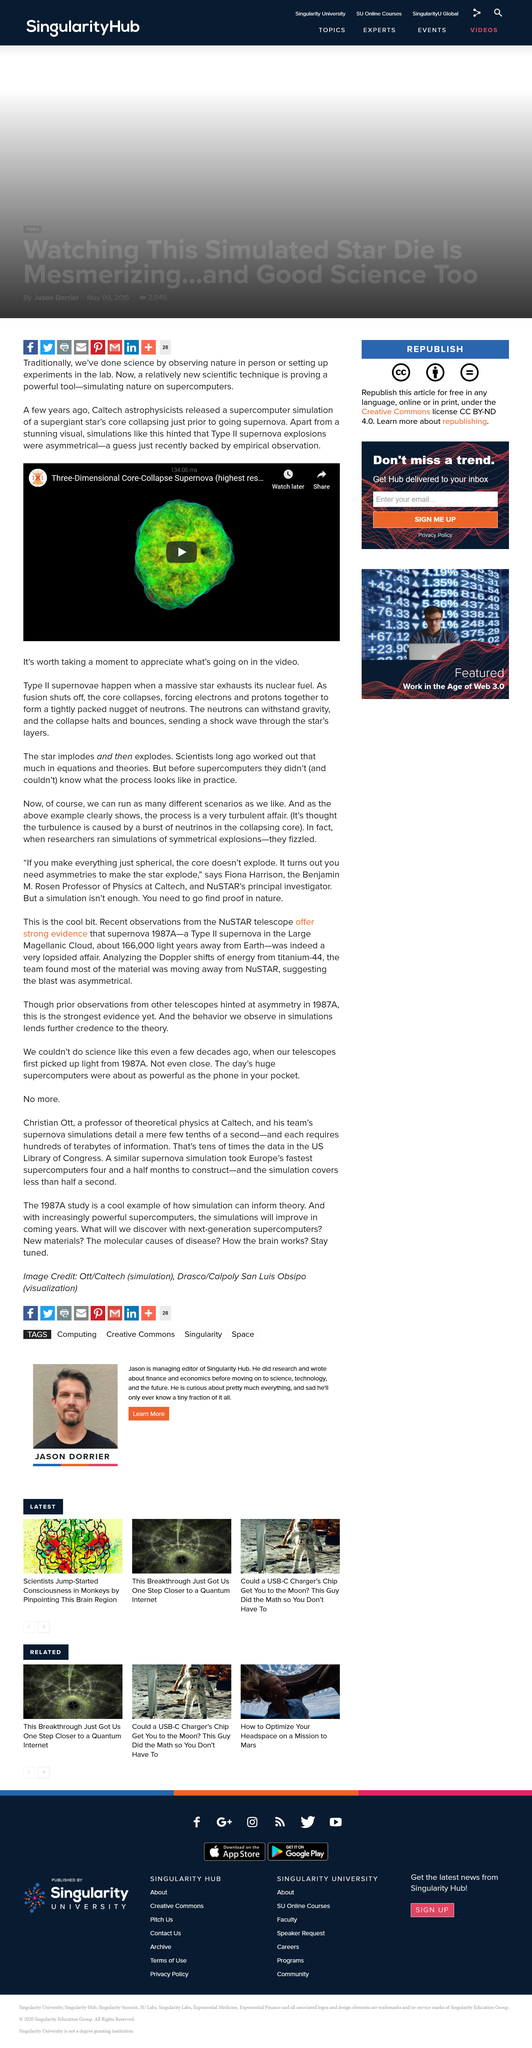Indicate a few pertinent items in this graphic. The simulation released hinted that Type II supernova explosions were asymmetrical. Type II supernovae occur when a star with a mass between about eight and twenty times that of the sun, has consumed all of its nuclear fuel and collapses under its own weight. Caltech astrophysicists have released a supercomputer simulation of a supergiant star's core collapse. 